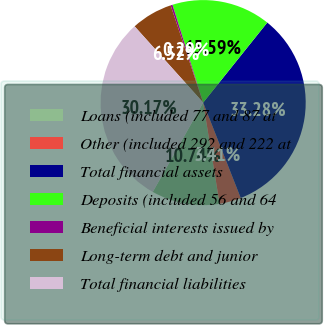Convert chart to OTSL. <chart><loc_0><loc_0><loc_500><loc_500><pie_chart><fcel>Loans (included 77 and 87 at<fcel>Other (included 292 and 222 at<fcel>Total financial assets<fcel>Deposits (included 56 and 64<fcel>Beneficial interests issued by<fcel>Long-term debt and junior<fcel>Total financial liabilities<nl><fcel>10.74%<fcel>3.41%<fcel>33.28%<fcel>15.59%<fcel>0.29%<fcel>6.52%<fcel>30.17%<nl></chart> 